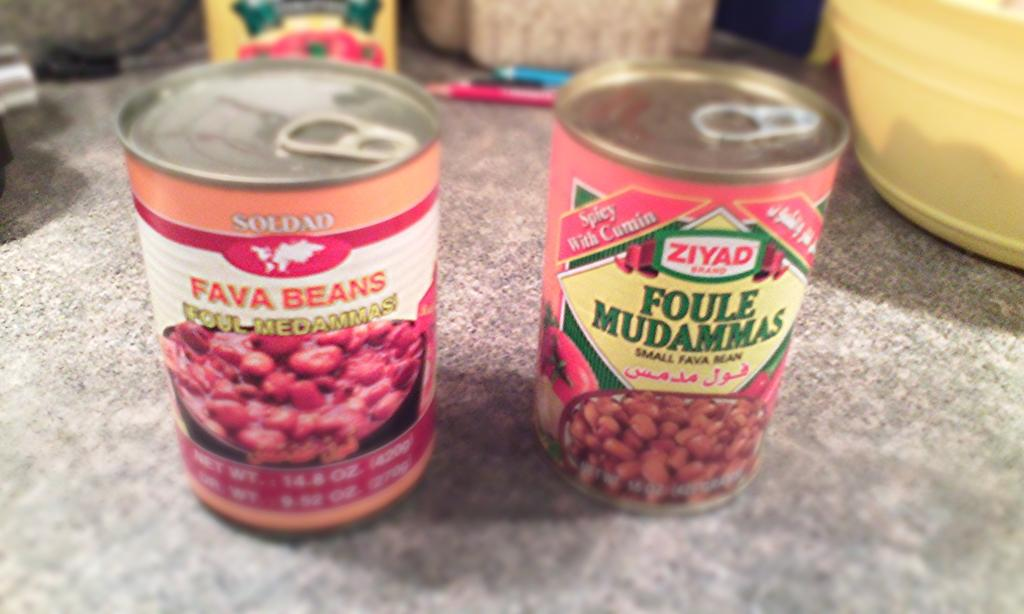<image>
Summarize the visual content of the image. Two cans of beans sit on a table, one reading "fava beans" and the other reading "foule mudammas." 